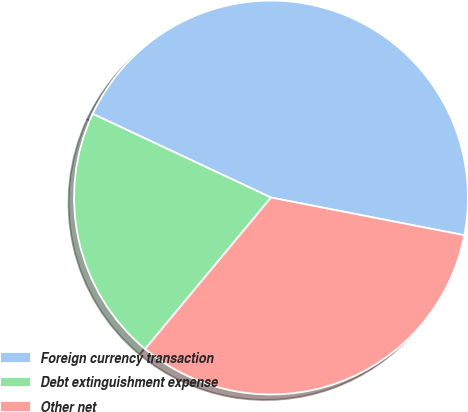<chart> <loc_0><loc_0><loc_500><loc_500><pie_chart><fcel>Foreign currency transaction<fcel>Debt extinguishment expense<fcel>Other net<nl><fcel>46.08%<fcel>20.95%<fcel>32.97%<nl></chart> 